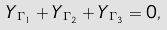<formula> <loc_0><loc_0><loc_500><loc_500>Y _ { \Gamma _ { 1 } } + Y _ { \Gamma _ { 2 } } + Y _ { \Gamma _ { 3 } } = 0 ,</formula> 